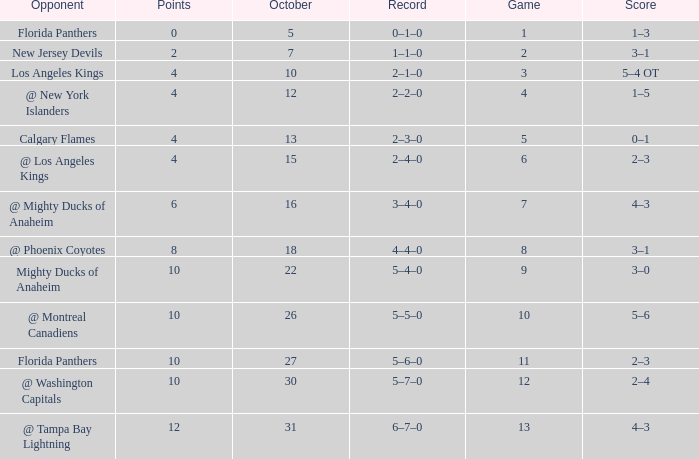Can you give me this table as a dict? {'header': ['Opponent', 'Points', 'October', 'Record', 'Game', 'Score'], 'rows': [['Florida Panthers', '0', '5', '0–1–0', '1', '1–3'], ['New Jersey Devils', '2', '7', '1–1–0', '2', '3–1'], ['Los Angeles Kings', '4', '10', '2–1–0', '3', '5–4 OT'], ['@ New York Islanders', '4', '12', '2–2–0', '4', '1–5'], ['Calgary Flames', '4', '13', '2–3–0', '5', '0–1'], ['@ Los Angeles Kings', '4', '15', '2–4–0', '6', '2–3'], ['@ Mighty Ducks of Anaheim', '6', '16', '3–4–0', '7', '4–3'], ['@ Phoenix Coyotes', '8', '18', '4–4–0', '8', '3–1'], ['Mighty Ducks of Anaheim', '10', '22', '5–4–0', '9', '3–0'], ['@ Montreal Canadiens', '10', '26', '5–5–0', '10', '5–6'], ['Florida Panthers', '10', '27', '5–6–0', '11', '2–3'], ['@ Washington Capitals', '10', '30', '5–7–0', '12', '2–4'], ['@ Tampa Bay Lightning', '12', '31', '6–7–0', '13', '4–3']]} What team has a score of 2 3–1. 